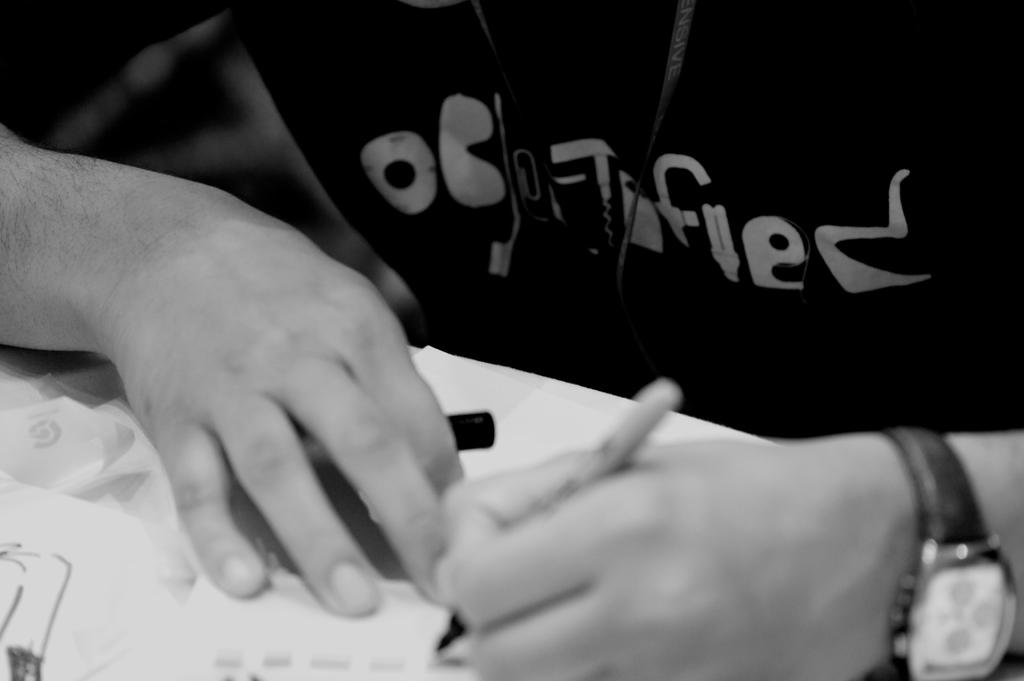What is the person in the image doing? The person is writing on a paper. What is the color scheme of the image? The image is black and white. What type of juice is the squirrel drinking in the image? There is no squirrel or juice present in the image. What things can be seen in the image besides the person and the paper? There are no other things visible in the image besides the person and the paper. 